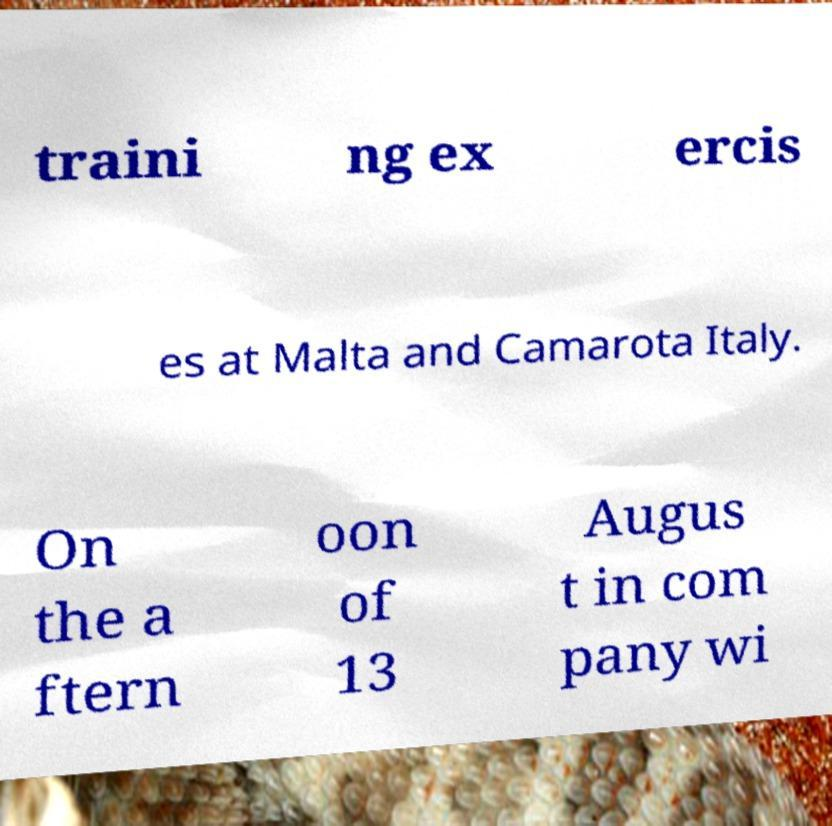Could you assist in decoding the text presented in this image and type it out clearly? traini ng ex ercis es at Malta and Camarota Italy. On the a ftern oon of 13 Augus t in com pany wi 